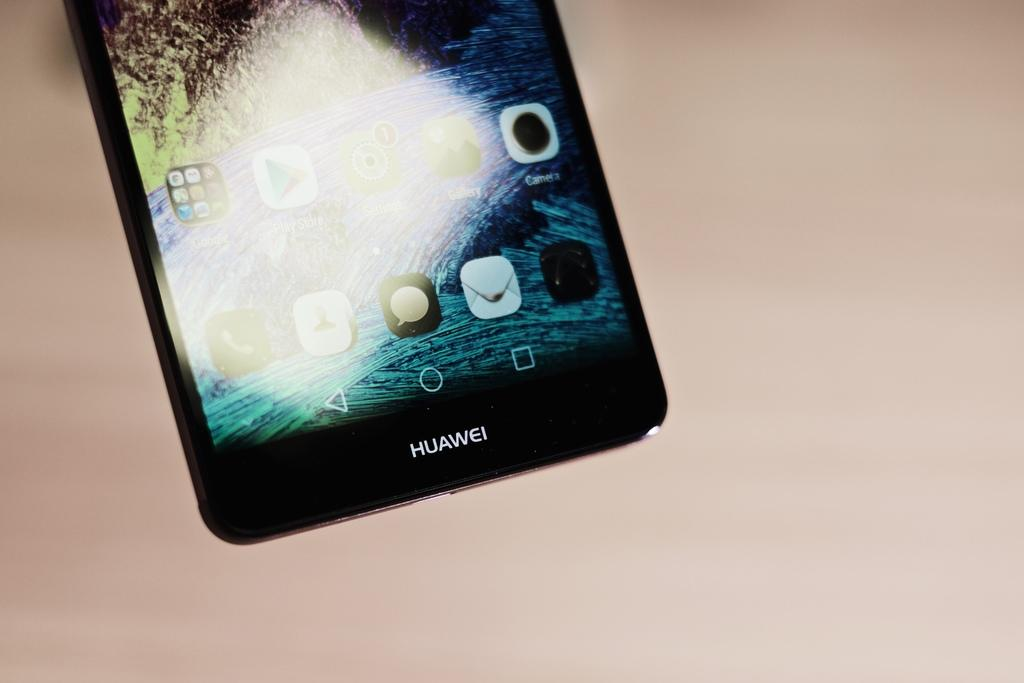Provide a one-sentence caption for the provided image. An iphone with the word Huawei on the bottom. 